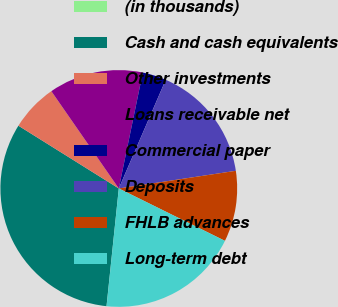Convert chart. <chart><loc_0><loc_0><loc_500><loc_500><pie_chart><fcel>(in thousands)<fcel>Cash and cash equivalents<fcel>Other investments<fcel>Loans receivable net<fcel>Commercial paper<fcel>Deposits<fcel>FHLB advances<fcel>Long-term debt<nl><fcel>0.01%<fcel>32.24%<fcel>6.46%<fcel>12.9%<fcel>3.24%<fcel>16.13%<fcel>9.68%<fcel>19.35%<nl></chart> 